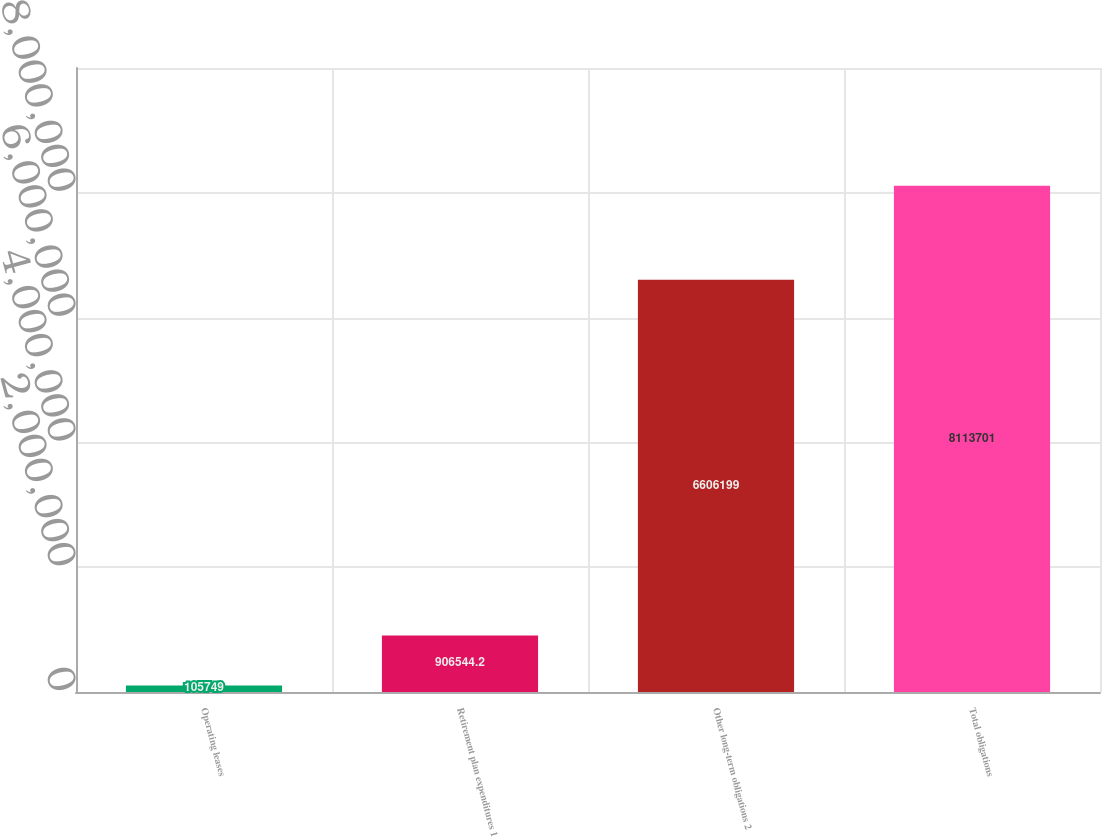<chart> <loc_0><loc_0><loc_500><loc_500><bar_chart><fcel>Operating leases<fcel>Retirement plan expenditures 1<fcel>Other long-term obligations 2<fcel>Total obligations<nl><fcel>105749<fcel>906544<fcel>6.6062e+06<fcel>8.1137e+06<nl></chart> 